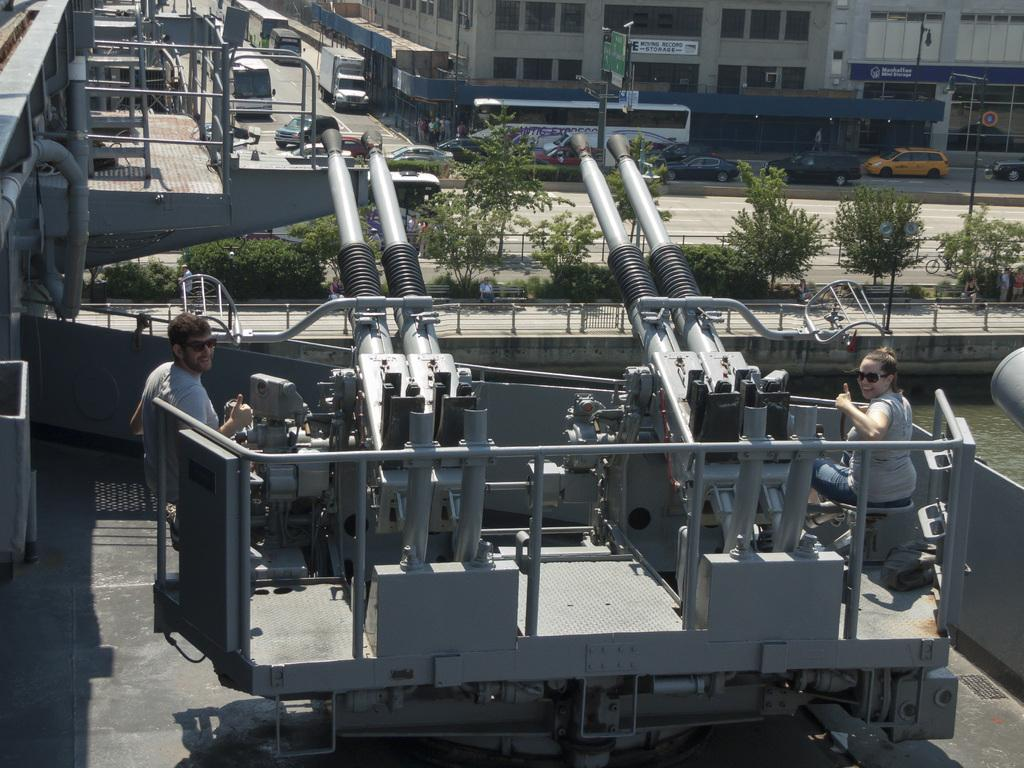What are the two persons in the image doing? The two persons in the image are sitting and smiling. What objects can be seen in the image that are typically used for warfare? There are cannons in the image. What type of transportation can be seen on the road in the image? There are vehicles on the road in the image. What type of vegetation is present in the image? There are trees in the image. What type of structures can be seen in the background of the image? There are buildings in the background of the image. What type of sense can be seen in the image? There is no sense present in the image; it is a visual representation. How many oranges are visible in the image? There are no oranges present in the image. 